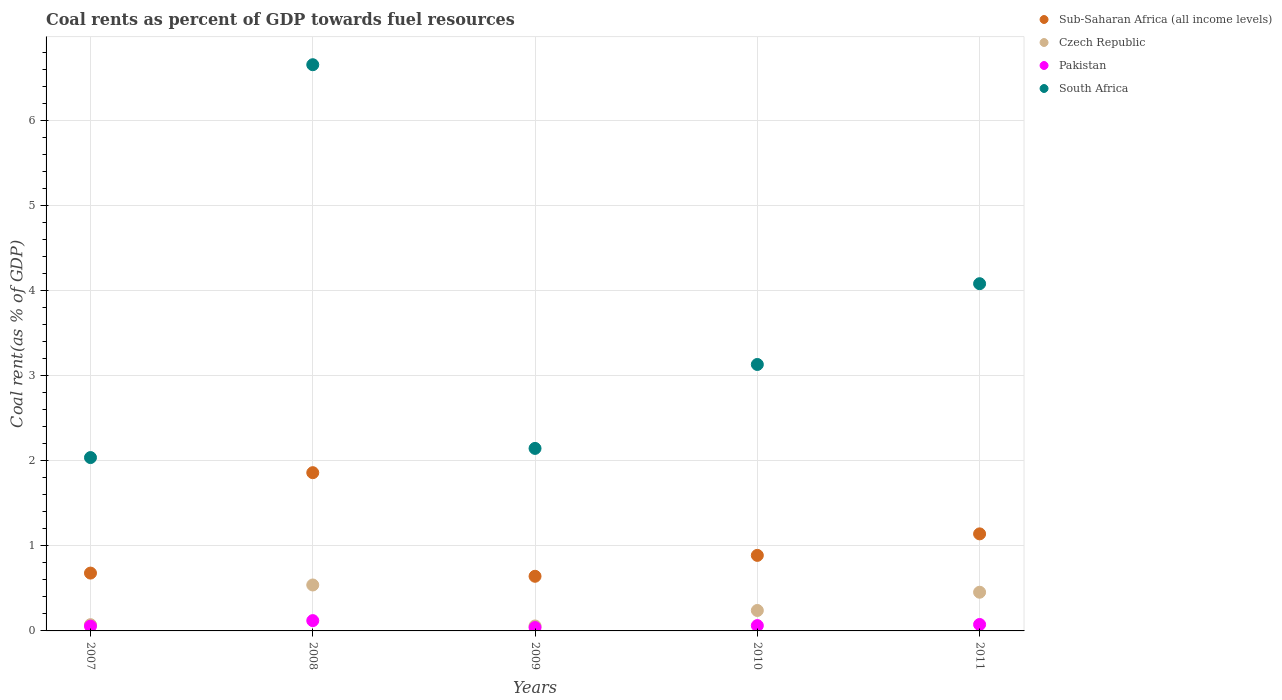How many different coloured dotlines are there?
Ensure brevity in your answer.  4. What is the coal rent in South Africa in 2010?
Provide a short and direct response. 3.13. Across all years, what is the maximum coal rent in Czech Republic?
Provide a short and direct response. 0.54. Across all years, what is the minimum coal rent in South Africa?
Ensure brevity in your answer.  2.04. In which year was the coal rent in Pakistan maximum?
Offer a very short reply. 2008. What is the total coal rent in South Africa in the graph?
Your response must be concise. 18.07. What is the difference between the coal rent in Pakistan in 2007 and that in 2011?
Ensure brevity in your answer.  -0.02. What is the difference between the coal rent in South Africa in 2007 and the coal rent in Pakistan in 2009?
Offer a terse response. 2. What is the average coal rent in Sub-Saharan Africa (all income levels) per year?
Ensure brevity in your answer.  1.04. In the year 2007, what is the difference between the coal rent in South Africa and coal rent in Sub-Saharan Africa (all income levels)?
Your answer should be very brief. 1.36. What is the ratio of the coal rent in South Africa in 2009 to that in 2010?
Give a very brief answer. 0.68. Is the coal rent in Czech Republic in 2009 less than that in 2010?
Your answer should be very brief. Yes. Is the difference between the coal rent in South Africa in 2007 and 2009 greater than the difference between the coal rent in Sub-Saharan Africa (all income levels) in 2007 and 2009?
Provide a succinct answer. No. What is the difference between the highest and the second highest coal rent in Czech Republic?
Your answer should be compact. 0.09. What is the difference between the highest and the lowest coal rent in Czech Republic?
Offer a very short reply. 0.48. Is the sum of the coal rent in South Africa in 2008 and 2011 greater than the maximum coal rent in Sub-Saharan Africa (all income levels) across all years?
Your response must be concise. Yes. Is it the case that in every year, the sum of the coal rent in Czech Republic and coal rent in Sub-Saharan Africa (all income levels)  is greater than the sum of coal rent in South Africa and coal rent in Pakistan?
Your response must be concise. No. Does the coal rent in Pakistan monotonically increase over the years?
Give a very brief answer. No. What is the difference between two consecutive major ticks on the Y-axis?
Your answer should be compact. 1. Does the graph contain any zero values?
Your answer should be compact. No. Does the graph contain grids?
Your answer should be compact. Yes. Where does the legend appear in the graph?
Your response must be concise. Top right. How many legend labels are there?
Ensure brevity in your answer.  4. How are the legend labels stacked?
Offer a very short reply. Vertical. What is the title of the graph?
Provide a succinct answer. Coal rents as percent of GDP towards fuel resources. Does "Ukraine" appear as one of the legend labels in the graph?
Your response must be concise. No. What is the label or title of the X-axis?
Keep it short and to the point. Years. What is the label or title of the Y-axis?
Keep it short and to the point. Coal rent(as % of GDP). What is the Coal rent(as % of GDP) of Sub-Saharan Africa (all income levels) in 2007?
Offer a terse response. 0.68. What is the Coal rent(as % of GDP) of Czech Republic in 2007?
Offer a very short reply. 0.07. What is the Coal rent(as % of GDP) of Pakistan in 2007?
Give a very brief answer. 0.06. What is the Coal rent(as % of GDP) in South Africa in 2007?
Make the answer very short. 2.04. What is the Coal rent(as % of GDP) in Sub-Saharan Africa (all income levels) in 2008?
Ensure brevity in your answer.  1.86. What is the Coal rent(as % of GDP) of Czech Republic in 2008?
Ensure brevity in your answer.  0.54. What is the Coal rent(as % of GDP) in Pakistan in 2008?
Keep it short and to the point. 0.12. What is the Coal rent(as % of GDP) of South Africa in 2008?
Your answer should be compact. 6.66. What is the Coal rent(as % of GDP) of Sub-Saharan Africa (all income levels) in 2009?
Your answer should be very brief. 0.64. What is the Coal rent(as % of GDP) in Czech Republic in 2009?
Offer a very short reply. 0.06. What is the Coal rent(as % of GDP) of Pakistan in 2009?
Provide a short and direct response. 0.04. What is the Coal rent(as % of GDP) of South Africa in 2009?
Your answer should be very brief. 2.15. What is the Coal rent(as % of GDP) in Sub-Saharan Africa (all income levels) in 2010?
Offer a very short reply. 0.89. What is the Coal rent(as % of GDP) in Czech Republic in 2010?
Give a very brief answer. 0.24. What is the Coal rent(as % of GDP) of Pakistan in 2010?
Your answer should be very brief. 0.06. What is the Coal rent(as % of GDP) in South Africa in 2010?
Give a very brief answer. 3.13. What is the Coal rent(as % of GDP) in Sub-Saharan Africa (all income levels) in 2011?
Your answer should be compact. 1.14. What is the Coal rent(as % of GDP) of Czech Republic in 2011?
Provide a succinct answer. 0.46. What is the Coal rent(as % of GDP) in Pakistan in 2011?
Make the answer very short. 0.08. What is the Coal rent(as % of GDP) of South Africa in 2011?
Your answer should be very brief. 4.08. Across all years, what is the maximum Coal rent(as % of GDP) in Sub-Saharan Africa (all income levels)?
Make the answer very short. 1.86. Across all years, what is the maximum Coal rent(as % of GDP) of Czech Republic?
Your answer should be very brief. 0.54. Across all years, what is the maximum Coal rent(as % of GDP) of Pakistan?
Provide a succinct answer. 0.12. Across all years, what is the maximum Coal rent(as % of GDP) of South Africa?
Ensure brevity in your answer.  6.66. Across all years, what is the minimum Coal rent(as % of GDP) in Sub-Saharan Africa (all income levels)?
Your answer should be very brief. 0.64. Across all years, what is the minimum Coal rent(as % of GDP) of Czech Republic?
Provide a short and direct response. 0.06. Across all years, what is the minimum Coal rent(as % of GDP) in Pakistan?
Provide a short and direct response. 0.04. Across all years, what is the minimum Coal rent(as % of GDP) in South Africa?
Keep it short and to the point. 2.04. What is the total Coal rent(as % of GDP) in Sub-Saharan Africa (all income levels) in the graph?
Your answer should be very brief. 5.21. What is the total Coal rent(as % of GDP) in Czech Republic in the graph?
Offer a very short reply. 1.37. What is the total Coal rent(as % of GDP) of Pakistan in the graph?
Your answer should be compact. 0.36. What is the total Coal rent(as % of GDP) of South Africa in the graph?
Your answer should be very brief. 18.07. What is the difference between the Coal rent(as % of GDP) of Sub-Saharan Africa (all income levels) in 2007 and that in 2008?
Provide a succinct answer. -1.18. What is the difference between the Coal rent(as % of GDP) in Czech Republic in 2007 and that in 2008?
Your response must be concise. -0.47. What is the difference between the Coal rent(as % of GDP) of Pakistan in 2007 and that in 2008?
Provide a short and direct response. -0.07. What is the difference between the Coal rent(as % of GDP) in South Africa in 2007 and that in 2008?
Make the answer very short. -4.62. What is the difference between the Coal rent(as % of GDP) of Sub-Saharan Africa (all income levels) in 2007 and that in 2009?
Offer a very short reply. 0.04. What is the difference between the Coal rent(as % of GDP) of Czech Republic in 2007 and that in 2009?
Give a very brief answer. 0.01. What is the difference between the Coal rent(as % of GDP) in Pakistan in 2007 and that in 2009?
Provide a succinct answer. 0.02. What is the difference between the Coal rent(as % of GDP) of South Africa in 2007 and that in 2009?
Your answer should be compact. -0.11. What is the difference between the Coal rent(as % of GDP) in Sub-Saharan Africa (all income levels) in 2007 and that in 2010?
Your answer should be very brief. -0.21. What is the difference between the Coal rent(as % of GDP) of Czech Republic in 2007 and that in 2010?
Ensure brevity in your answer.  -0.17. What is the difference between the Coal rent(as % of GDP) in Pakistan in 2007 and that in 2010?
Give a very brief answer. -0.01. What is the difference between the Coal rent(as % of GDP) in South Africa in 2007 and that in 2010?
Provide a succinct answer. -1.1. What is the difference between the Coal rent(as % of GDP) of Sub-Saharan Africa (all income levels) in 2007 and that in 2011?
Give a very brief answer. -0.46. What is the difference between the Coal rent(as % of GDP) in Czech Republic in 2007 and that in 2011?
Your answer should be very brief. -0.38. What is the difference between the Coal rent(as % of GDP) of Pakistan in 2007 and that in 2011?
Make the answer very short. -0.02. What is the difference between the Coal rent(as % of GDP) in South Africa in 2007 and that in 2011?
Keep it short and to the point. -2.05. What is the difference between the Coal rent(as % of GDP) in Sub-Saharan Africa (all income levels) in 2008 and that in 2009?
Provide a succinct answer. 1.22. What is the difference between the Coal rent(as % of GDP) in Czech Republic in 2008 and that in 2009?
Ensure brevity in your answer.  0.48. What is the difference between the Coal rent(as % of GDP) in Pakistan in 2008 and that in 2009?
Offer a terse response. 0.08. What is the difference between the Coal rent(as % of GDP) of South Africa in 2008 and that in 2009?
Offer a very short reply. 4.51. What is the difference between the Coal rent(as % of GDP) of Sub-Saharan Africa (all income levels) in 2008 and that in 2010?
Offer a very short reply. 0.97. What is the difference between the Coal rent(as % of GDP) of Pakistan in 2008 and that in 2010?
Ensure brevity in your answer.  0.06. What is the difference between the Coal rent(as % of GDP) of South Africa in 2008 and that in 2010?
Keep it short and to the point. 3.53. What is the difference between the Coal rent(as % of GDP) in Sub-Saharan Africa (all income levels) in 2008 and that in 2011?
Offer a very short reply. 0.72. What is the difference between the Coal rent(as % of GDP) of Czech Republic in 2008 and that in 2011?
Provide a short and direct response. 0.09. What is the difference between the Coal rent(as % of GDP) in Pakistan in 2008 and that in 2011?
Provide a succinct answer. 0.05. What is the difference between the Coal rent(as % of GDP) in South Africa in 2008 and that in 2011?
Keep it short and to the point. 2.58. What is the difference between the Coal rent(as % of GDP) in Sub-Saharan Africa (all income levels) in 2009 and that in 2010?
Ensure brevity in your answer.  -0.25. What is the difference between the Coal rent(as % of GDP) of Czech Republic in 2009 and that in 2010?
Give a very brief answer. -0.18. What is the difference between the Coal rent(as % of GDP) in Pakistan in 2009 and that in 2010?
Ensure brevity in your answer.  -0.02. What is the difference between the Coal rent(as % of GDP) in South Africa in 2009 and that in 2010?
Offer a terse response. -0.99. What is the difference between the Coal rent(as % of GDP) in Sub-Saharan Africa (all income levels) in 2009 and that in 2011?
Provide a succinct answer. -0.5. What is the difference between the Coal rent(as % of GDP) in Czech Republic in 2009 and that in 2011?
Keep it short and to the point. -0.4. What is the difference between the Coal rent(as % of GDP) in Pakistan in 2009 and that in 2011?
Your answer should be compact. -0.04. What is the difference between the Coal rent(as % of GDP) in South Africa in 2009 and that in 2011?
Provide a succinct answer. -1.94. What is the difference between the Coal rent(as % of GDP) of Sub-Saharan Africa (all income levels) in 2010 and that in 2011?
Make the answer very short. -0.25. What is the difference between the Coal rent(as % of GDP) of Czech Republic in 2010 and that in 2011?
Give a very brief answer. -0.21. What is the difference between the Coal rent(as % of GDP) of Pakistan in 2010 and that in 2011?
Offer a very short reply. -0.01. What is the difference between the Coal rent(as % of GDP) in South Africa in 2010 and that in 2011?
Your answer should be compact. -0.95. What is the difference between the Coal rent(as % of GDP) of Sub-Saharan Africa (all income levels) in 2007 and the Coal rent(as % of GDP) of Czech Republic in 2008?
Provide a short and direct response. 0.14. What is the difference between the Coal rent(as % of GDP) of Sub-Saharan Africa (all income levels) in 2007 and the Coal rent(as % of GDP) of Pakistan in 2008?
Provide a succinct answer. 0.56. What is the difference between the Coal rent(as % of GDP) in Sub-Saharan Africa (all income levels) in 2007 and the Coal rent(as % of GDP) in South Africa in 2008?
Ensure brevity in your answer.  -5.98. What is the difference between the Coal rent(as % of GDP) in Czech Republic in 2007 and the Coal rent(as % of GDP) in Pakistan in 2008?
Provide a short and direct response. -0.05. What is the difference between the Coal rent(as % of GDP) of Czech Republic in 2007 and the Coal rent(as % of GDP) of South Africa in 2008?
Offer a very short reply. -6.59. What is the difference between the Coal rent(as % of GDP) in Pakistan in 2007 and the Coal rent(as % of GDP) in South Africa in 2008?
Offer a terse response. -6.6. What is the difference between the Coal rent(as % of GDP) of Sub-Saharan Africa (all income levels) in 2007 and the Coal rent(as % of GDP) of Czech Republic in 2009?
Offer a very short reply. 0.62. What is the difference between the Coal rent(as % of GDP) in Sub-Saharan Africa (all income levels) in 2007 and the Coal rent(as % of GDP) in Pakistan in 2009?
Ensure brevity in your answer.  0.64. What is the difference between the Coal rent(as % of GDP) of Sub-Saharan Africa (all income levels) in 2007 and the Coal rent(as % of GDP) of South Africa in 2009?
Provide a short and direct response. -1.47. What is the difference between the Coal rent(as % of GDP) of Czech Republic in 2007 and the Coal rent(as % of GDP) of Pakistan in 2009?
Keep it short and to the point. 0.03. What is the difference between the Coal rent(as % of GDP) of Czech Republic in 2007 and the Coal rent(as % of GDP) of South Africa in 2009?
Offer a very short reply. -2.07. What is the difference between the Coal rent(as % of GDP) in Pakistan in 2007 and the Coal rent(as % of GDP) in South Africa in 2009?
Make the answer very short. -2.09. What is the difference between the Coal rent(as % of GDP) of Sub-Saharan Africa (all income levels) in 2007 and the Coal rent(as % of GDP) of Czech Republic in 2010?
Give a very brief answer. 0.44. What is the difference between the Coal rent(as % of GDP) in Sub-Saharan Africa (all income levels) in 2007 and the Coal rent(as % of GDP) in Pakistan in 2010?
Offer a terse response. 0.62. What is the difference between the Coal rent(as % of GDP) in Sub-Saharan Africa (all income levels) in 2007 and the Coal rent(as % of GDP) in South Africa in 2010?
Keep it short and to the point. -2.45. What is the difference between the Coal rent(as % of GDP) of Czech Republic in 2007 and the Coal rent(as % of GDP) of Pakistan in 2010?
Your answer should be very brief. 0.01. What is the difference between the Coal rent(as % of GDP) in Czech Republic in 2007 and the Coal rent(as % of GDP) in South Africa in 2010?
Offer a very short reply. -3.06. What is the difference between the Coal rent(as % of GDP) of Pakistan in 2007 and the Coal rent(as % of GDP) of South Africa in 2010?
Give a very brief answer. -3.08. What is the difference between the Coal rent(as % of GDP) of Sub-Saharan Africa (all income levels) in 2007 and the Coal rent(as % of GDP) of Czech Republic in 2011?
Provide a succinct answer. 0.23. What is the difference between the Coal rent(as % of GDP) of Sub-Saharan Africa (all income levels) in 2007 and the Coal rent(as % of GDP) of Pakistan in 2011?
Provide a succinct answer. 0.6. What is the difference between the Coal rent(as % of GDP) of Sub-Saharan Africa (all income levels) in 2007 and the Coal rent(as % of GDP) of South Africa in 2011?
Provide a short and direct response. -3.4. What is the difference between the Coal rent(as % of GDP) in Czech Republic in 2007 and the Coal rent(as % of GDP) in Pakistan in 2011?
Your response must be concise. -0. What is the difference between the Coal rent(as % of GDP) in Czech Republic in 2007 and the Coal rent(as % of GDP) in South Africa in 2011?
Offer a terse response. -4.01. What is the difference between the Coal rent(as % of GDP) of Pakistan in 2007 and the Coal rent(as % of GDP) of South Africa in 2011?
Your answer should be very brief. -4.03. What is the difference between the Coal rent(as % of GDP) of Sub-Saharan Africa (all income levels) in 2008 and the Coal rent(as % of GDP) of Czech Republic in 2009?
Your response must be concise. 1.8. What is the difference between the Coal rent(as % of GDP) in Sub-Saharan Africa (all income levels) in 2008 and the Coal rent(as % of GDP) in Pakistan in 2009?
Your answer should be compact. 1.82. What is the difference between the Coal rent(as % of GDP) in Sub-Saharan Africa (all income levels) in 2008 and the Coal rent(as % of GDP) in South Africa in 2009?
Your answer should be very brief. -0.29. What is the difference between the Coal rent(as % of GDP) of Czech Republic in 2008 and the Coal rent(as % of GDP) of Pakistan in 2009?
Keep it short and to the point. 0.5. What is the difference between the Coal rent(as % of GDP) in Czech Republic in 2008 and the Coal rent(as % of GDP) in South Africa in 2009?
Your answer should be very brief. -1.61. What is the difference between the Coal rent(as % of GDP) of Pakistan in 2008 and the Coal rent(as % of GDP) of South Africa in 2009?
Your answer should be compact. -2.03. What is the difference between the Coal rent(as % of GDP) of Sub-Saharan Africa (all income levels) in 2008 and the Coal rent(as % of GDP) of Czech Republic in 2010?
Provide a succinct answer. 1.62. What is the difference between the Coal rent(as % of GDP) in Sub-Saharan Africa (all income levels) in 2008 and the Coal rent(as % of GDP) in Pakistan in 2010?
Keep it short and to the point. 1.8. What is the difference between the Coal rent(as % of GDP) in Sub-Saharan Africa (all income levels) in 2008 and the Coal rent(as % of GDP) in South Africa in 2010?
Make the answer very short. -1.27. What is the difference between the Coal rent(as % of GDP) of Czech Republic in 2008 and the Coal rent(as % of GDP) of Pakistan in 2010?
Give a very brief answer. 0.48. What is the difference between the Coal rent(as % of GDP) of Czech Republic in 2008 and the Coal rent(as % of GDP) of South Africa in 2010?
Your answer should be very brief. -2.59. What is the difference between the Coal rent(as % of GDP) of Pakistan in 2008 and the Coal rent(as % of GDP) of South Africa in 2010?
Your answer should be compact. -3.01. What is the difference between the Coal rent(as % of GDP) of Sub-Saharan Africa (all income levels) in 2008 and the Coal rent(as % of GDP) of Czech Republic in 2011?
Your answer should be very brief. 1.41. What is the difference between the Coal rent(as % of GDP) of Sub-Saharan Africa (all income levels) in 2008 and the Coal rent(as % of GDP) of Pakistan in 2011?
Provide a short and direct response. 1.79. What is the difference between the Coal rent(as % of GDP) of Sub-Saharan Africa (all income levels) in 2008 and the Coal rent(as % of GDP) of South Africa in 2011?
Offer a very short reply. -2.22. What is the difference between the Coal rent(as % of GDP) of Czech Republic in 2008 and the Coal rent(as % of GDP) of Pakistan in 2011?
Give a very brief answer. 0.46. What is the difference between the Coal rent(as % of GDP) in Czech Republic in 2008 and the Coal rent(as % of GDP) in South Africa in 2011?
Offer a terse response. -3.54. What is the difference between the Coal rent(as % of GDP) in Pakistan in 2008 and the Coal rent(as % of GDP) in South Africa in 2011?
Ensure brevity in your answer.  -3.96. What is the difference between the Coal rent(as % of GDP) in Sub-Saharan Africa (all income levels) in 2009 and the Coal rent(as % of GDP) in Czech Republic in 2010?
Make the answer very short. 0.4. What is the difference between the Coal rent(as % of GDP) in Sub-Saharan Africa (all income levels) in 2009 and the Coal rent(as % of GDP) in Pakistan in 2010?
Make the answer very short. 0.58. What is the difference between the Coal rent(as % of GDP) in Sub-Saharan Africa (all income levels) in 2009 and the Coal rent(as % of GDP) in South Africa in 2010?
Your answer should be compact. -2.49. What is the difference between the Coal rent(as % of GDP) in Czech Republic in 2009 and the Coal rent(as % of GDP) in Pakistan in 2010?
Your answer should be very brief. -0. What is the difference between the Coal rent(as % of GDP) in Czech Republic in 2009 and the Coal rent(as % of GDP) in South Africa in 2010?
Give a very brief answer. -3.08. What is the difference between the Coal rent(as % of GDP) in Pakistan in 2009 and the Coal rent(as % of GDP) in South Africa in 2010?
Keep it short and to the point. -3.09. What is the difference between the Coal rent(as % of GDP) in Sub-Saharan Africa (all income levels) in 2009 and the Coal rent(as % of GDP) in Czech Republic in 2011?
Offer a terse response. 0.19. What is the difference between the Coal rent(as % of GDP) in Sub-Saharan Africa (all income levels) in 2009 and the Coal rent(as % of GDP) in Pakistan in 2011?
Keep it short and to the point. 0.57. What is the difference between the Coal rent(as % of GDP) of Sub-Saharan Africa (all income levels) in 2009 and the Coal rent(as % of GDP) of South Africa in 2011?
Keep it short and to the point. -3.44. What is the difference between the Coal rent(as % of GDP) in Czech Republic in 2009 and the Coal rent(as % of GDP) in Pakistan in 2011?
Your answer should be very brief. -0.02. What is the difference between the Coal rent(as % of GDP) in Czech Republic in 2009 and the Coal rent(as % of GDP) in South Africa in 2011?
Your response must be concise. -4.03. What is the difference between the Coal rent(as % of GDP) in Pakistan in 2009 and the Coal rent(as % of GDP) in South Africa in 2011?
Offer a very short reply. -4.04. What is the difference between the Coal rent(as % of GDP) of Sub-Saharan Africa (all income levels) in 2010 and the Coal rent(as % of GDP) of Czech Republic in 2011?
Your answer should be very brief. 0.43. What is the difference between the Coal rent(as % of GDP) in Sub-Saharan Africa (all income levels) in 2010 and the Coal rent(as % of GDP) in Pakistan in 2011?
Offer a terse response. 0.81. What is the difference between the Coal rent(as % of GDP) in Sub-Saharan Africa (all income levels) in 2010 and the Coal rent(as % of GDP) in South Africa in 2011?
Make the answer very short. -3.2. What is the difference between the Coal rent(as % of GDP) in Czech Republic in 2010 and the Coal rent(as % of GDP) in Pakistan in 2011?
Your answer should be very brief. 0.16. What is the difference between the Coal rent(as % of GDP) of Czech Republic in 2010 and the Coal rent(as % of GDP) of South Africa in 2011?
Ensure brevity in your answer.  -3.84. What is the difference between the Coal rent(as % of GDP) of Pakistan in 2010 and the Coal rent(as % of GDP) of South Africa in 2011?
Offer a very short reply. -4.02. What is the average Coal rent(as % of GDP) of Sub-Saharan Africa (all income levels) per year?
Make the answer very short. 1.04. What is the average Coal rent(as % of GDP) in Czech Republic per year?
Ensure brevity in your answer.  0.27. What is the average Coal rent(as % of GDP) of Pakistan per year?
Give a very brief answer. 0.07. What is the average Coal rent(as % of GDP) in South Africa per year?
Provide a succinct answer. 3.61. In the year 2007, what is the difference between the Coal rent(as % of GDP) of Sub-Saharan Africa (all income levels) and Coal rent(as % of GDP) of Czech Republic?
Offer a very short reply. 0.61. In the year 2007, what is the difference between the Coal rent(as % of GDP) in Sub-Saharan Africa (all income levels) and Coal rent(as % of GDP) in Pakistan?
Ensure brevity in your answer.  0.62. In the year 2007, what is the difference between the Coal rent(as % of GDP) of Sub-Saharan Africa (all income levels) and Coal rent(as % of GDP) of South Africa?
Your answer should be very brief. -1.36. In the year 2007, what is the difference between the Coal rent(as % of GDP) of Czech Republic and Coal rent(as % of GDP) of Pakistan?
Keep it short and to the point. 0.02. In the year 2007, what is the difference between the Coal rent(as % of GDP) of Czech Republic and Coal rent(as % of GDP) of South Africa?
Your answer should be compact. -1.97. In the year 2007, what is the difference between the Coal rent(as % of GDP) in Pakistan and Coal rent(as % of GDP) in South Africa?
Ensure brevity in your answer.  -1.98. In the year 2008, what is the difference between the Coal rent(as % of GDP) in Sub-Saharan Africa (all income levels) and Coal rent(as % of GDP) in Czech Republic?
Your answer should be very brief. 1.32. In the year 2008, what is the difference between the Coal rent(as % of GDP) in Sub-Saharan Africa (all income levels) and Coal rent(as % of GDP) in Pakistan?
Your answer should be very brief. 1.74. In the year 2008, what is the difference between the Coal rent(as % of GDP) of Sub-Saharan Africa (all income levels) and Coal rent(as % of GDP) of South Africa?
Keep it short and to the point. -4.8. In the year 2008, what is the difference between the Coal rent(as % of GDP) in Czech Republic and Coal rent(as % of GDP) in Pakistan?
Offer a terse response. 0.42. In the year 2008, what is the difference between the Coal rent(as % of GDP) in Czech Republic and Coal rent(as % of GDP) in South Africa?
Provide a short and direct response. -6.12. In the year 2008, what is the difference between the Coal rent(as % of GDP) in Pakistan and Coal rent(as % of GDP) in South Africa?
Your answer should be very brief. -6.54. In the year 2009, what is the difference between the Coal rent(as % of GDP) of Sub-Saharan Africa (all income levels) and Coal rent(as % of GDP) of Czech Republic?
Offer a very short reply. 0.58. In the year 2009, what is the difference between the Coal rent(as % of GDP) of Sub-Saharan Africa (all income levels) and Coal rent(as % of GDP) of Pakistan?
Make the answer very short. 0.6. In the year 2009, what is the difference between the Coal rent(as % of GDP) in Sub-Saharan Africa (all income levels) and Coal rent(as % of GDP) in South Africa?
Give a very brief answer. -1.5. In the year 2009, what is the difference between the Coal rent(as % of GDP) of Czech Republic and Coal rent(as % of GDP) of Pakistan?
Make the answer very short. 0.02. In the year 2009, what is the difference between the Coal rent(as % of GDP) in Czech Republic and Coal rent(as % of GDP) in South Africa?
Your response must be concise. -2.09. In the year 2009, what is the difference between the Coal rent(as % of GDP) of Pakistan and Coal rent(as % of GDP) of South Africa?
Offer a very short reply. -2.11. In the year 2010, what is the difference between the Coal rent(as % of GDP) in Sub-Saharan Africa (all income levels) and Coal rent(as % of GDP) in Czech Republic?
Offer a very short reply. 0.65. In the year 2010, what is the difference between the Coal rent(as % of GDP) of Sub-Saharan Africa (all income levels) and Coal rent(as % of GDP) of Pakistan?
Your response must be concise. 0.83. In the year 2010, what is the difference between the Coal rent(as % of GDP) in Sub-Saharan Africa (all income levels) and Coal rent(as % of GDP) in South Africa?
Provide a short and direct response. -2.25. In the year 2010, what is the difference between the Coal rent(as % of GDP) of Czech Republic and Coal rent(as % of GDP) of Pakistan?
Your response must be concise. 0.18. In the year 2010, what is the difference between the Coal rent(as % of GDP) in Czech Republic and Coal rent(as % of GDP) in South Africa?
Provide a succinct answer. -2.89. In the year 2010, what is the difference between the Coal rent(as % of GDP) in Pakistan and Coal rent(as % of GDP) in South Africa?
Your answer should be compact. -3.07. In the year 2011, what is the difference between the Coal rent(as % of GDP) in Sub-Saharan Africa (all income levels) and Coal rent(as % of GDP) in Czech Republic?
Keep it short and to the point. 0.69. In the year 2011, what is the difference between the Coal rent(as % of GDP) in Sub-Saharan Africa (all income levels) and Coal rent(as % of GDP) in Pakistan?
Ensure brevity in your answer.  1.07. In the year 2011, what is the difference between the Coal rent(as % of GDP) of Sub-Saharan Africa (all income levels) and Coal rent(as % of GDP) of South Africa?
Ensure brevity in your answer.  -2.94. In the year 2011, what is the difference between the Coal rent(as % of GDP) in Czech Republic and Coal rent(as % of GDP) in Pakistan?
Ensure brevity in your answer.  0.38. In the year 2011, what is the difference between the Coal rent(as % of GDP) in Czech Republic and Coal rent(as % of GDP) in South Africa?
Your answer should be compact. -3.63. In the year 2011, what is the difference between the Coal rent(as % of GDP) of Pakistan and Coal rent(as % of GDP) of South Africa?
Offer a terse response. -4.01. What is the ratio of the Coal rent(as % of GDP) in Sub-Saharan Africa (all income levels) in 2007 to that in 2008?
Your response must be concise. 0.37. What is the ratio of the Coal rent(as % of GDP) of Czech Republic in 2007 to that in 2008?
Offer a very short reply. 0.14. What is the ratio of the Coal rent(as % of GDP) of Pakistan in 2007 to that in 2008?
Keep it short and to the point. 0.46. What is the ratio of the Coal rent(as % of GDP) in South Africa in 2007 to that in 2008?
Make the answer very short. 0.31. What is the ratio of the Coal rent(as % of GDP) in Sub-Saharan Africa (all income levels) in 2007 to that in 2009?
Provide a short and direct response. 1.06. What is the ratio of the Coal rent(as % of GDP) of Czech Republic in 2007 to that in 2009?
Offer a very short reply. 1.26. What is the ratio of the Coal rent(as % of GDP) in Pakistan in 2007 to that in 2009?
Your response must be concise. 1.42. What is the ratio of the Coal rent(as % of GDP) of South Africa in 2007 to that in 2009?
Offer a very short reply. 0.95. What is the ratio of the Coal rent(as % of GDP) in Sub-Saharan Africa (all income levels) in 2007 to that in 2010?
Offer a very short reply. 0.77. What is the ratio of the Coal rent(as % of GDP) of Czech Republic in 2007 to that in 2010?
Your response must be concise. 0.31. What is the ratio of the Coal rent(as % of GDP) in Pakistan in 2007 to that in 2010?
Provide a succinct answer. 0.9. What is the ratio of the Coal rent(as % of GDP) in South Africa in 2007 to that in 2010?
Give a very brief answer. 0.65. What is the ratio of the Coal rent(as % of GDP) in Sub-Saharan Africa (all income levels) in 2007 to that in 2011?
Give a very brief answer. 0.6. What is the ratio of the Coal rent(as % of GDP) in Czech Republic in 2007 to that in 2011?
Give a very brief answer. 0.16. What is the ratio of the Coal rent(as % of GDP) of Pakistan in 2007 to that in 2011?
Make the answer very short. 0.74. What is the ratio of the Coal rent(as % of GDP) in South Africa in 2007 to that in 2011?
Ensure brevity in your answer.  0.5. What is the ratio of the Coal rent(as % of GDP) in Sub-Saharan Africa (all income levels) in 2008 to that in 2009?
Your answer should be compact. 2.9. What is the ratio of the Coal rent(as % of GDP) in Czech Republic in 2008 to that in 2009?
Give a very brief answer. 9.24. What is the ratio of the Coal rent(as % of GDP) in Pakistan in 2008 to that in 2009?
Provide a succinct answer. 3.06. What is the ratio of the Coal rent(as % of GDP) in South Africa in 2008 to that in 2009?
Your response must be concise. 3.1. What is the ratio of the Coal rent(as % of GDP) in Sub-Saharan Africa (all income levels) in 2008 to that in 2010?
Provide a succinct answer. 2.09. What is the ratio of the Coal rent(as % of GDP) of Czech Republic in 2008 to that in 2010?
Your answer should be compact. 2.25. What is the ratio of the Coal rent(as % of GDP) of Pakistan in 2008 to that in 2010?
Offer a very short reply. 1.94. What is the ratio of the Coal rent(as % of GDP) of South Africa in 2008 to that in 2010?
Provide a succinct answer. 2.12. What is the ratio of the Coal rent(as % of GDP) of Sub-Saharan Africa (all income levels) in 2008 to that in 2011?
Keep it short and to the point. 1.63. What is the ratio of the Coal rent(as % of GDP) in Czech Republic in 2008 to that in 2011?
Provide a short and direct response. 1.19. What is the ratio of the Coal rent(as % of GDP) in Pakistan in 2008 to that in 2011?
Give a very brief answer. 1.6. What is the ratio of the Coal rent(as % of GDP) in South Africa in 2008 to that in 2011?
Your answer should be very brief. 1.63. What is the ratio of the Coal rent(as % of GDP) of Sub-Saharan Africa (all income levels) in 2009 to that in 2010?
Your response must be concise. 0.72. What is the ratio of the Coal rent(as % of GDP) in Czech Republic in 2009 to that in 2010?
Make the answer very short. 0.24. What is the ratio of the Coal rent(as % of GDP) of Pakistan in 2009 to that in 2010?
Give a very brief answer. 0.63. What is the ratio of the Coal rent(as % of GDP) of South Africa in 2009 to that in 2010?
Offer a very short reply. 0.69. What is the ratio of the Coal rent(as % of GDP) in Sub-Saharan Africa (all income levels) in 2009 to that in 2011?
Your answer should be compact. 0.56. What is the ratio of the Coal rent(as % of GDP) in Czech Republic in 2009 to that in 2011?
Offer a very short reply. 0.13. What is the ratio of the Coal rent(as % of GDP) in Pakistan in 2009 to that in 2011?
Keep it short and to the point. 0.52. What is the ratio of the Coal rent(as % of GDP) in South Africa in 2009 to that in 2011?
Offer a very short reply. 0.53. What is the ratio of the Coal rent(as % of GDP) of Sub-Saharan Africa (all income levels) in 2010 to that in 2011?
Offer a terse response. 0.78. What is the ratio of the Coal rent(as % of GDP) of Czech Republic in 2010 to that in 2011?
Your answer should be very brief. 0.53. What is the ratio of the Coal rent(as % of GDP) in Pakistan in 2010 to that in 2011?
Provide a short and direct response. 0.83. What is the ratio of the Coal rent(as % of GDP) of South Africa in 2010 to that in 2011?
Your answer should be compact. 0.77. What is the difference between the highest and the second highest Coal rent(as % of GDP) in Sub-Saharan Africa (all income levels)?
Offer a very short reply. 0.72. What is the difference between the highest and the second highest Coal rent(as % of GDP) of Czech Republic?
Provide a short and direct response. 0.09. What is the difference between the highest and the second highest Coal rent(as % of GDP) of Pakistan?
Your response must be concise. 0.05. What is the difference between the highest and the second highest Coal rent(as % of GDP) in South Africa?
Your answer should be compact. 2.58. What is the difference between the highest and the lowest Coal rent(as % of GDP) of Sub-Saharan Africa (all income levels)?
Give a very brief answer. 1.22. What is the difference between the highest and the lowest Coal rent(as % of GDP) in Czech Republic?
Make the answer very short. 0.48. What is the difference between the highest and the lowest Coal rent(as % of GDP) in Pakistan?
Provide a succinct answer. 0.08. What is the difference between the highest and the lowest Coal rent(as % of GDP) of South Africa?
Provide a short and direct response. 4.62. 